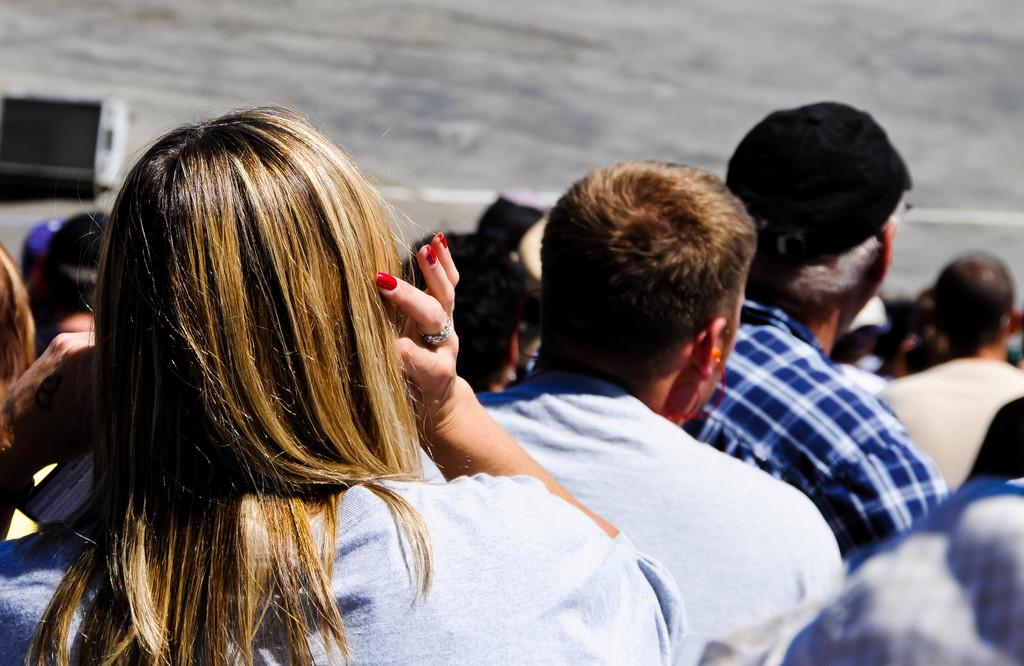Who can be seen in the image? There are people in the image. Can you describe the woman's position in the image? The woman is on the left side of the image. What can be observed about the background of the image? The background of the image is blurred. What note is the servant holding in the image? There is no servant or note present in the image. 